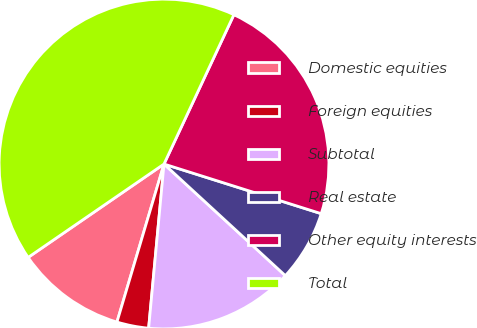Convert chart. <chart><loc_0><loc_0><loc_500><loc_500><pie_chart><fcel>Domestic equities<fcel>Foreign equities<fcel>Subtotal<fcel>Real estate<fcel>Other equity interests<fcel>Total<nl><fcel>10.81%<fcel>3.12%<fcel>14.65%<fcel>6.97%<fcel>22.9%<fcel>41.55%<nl></chart> 